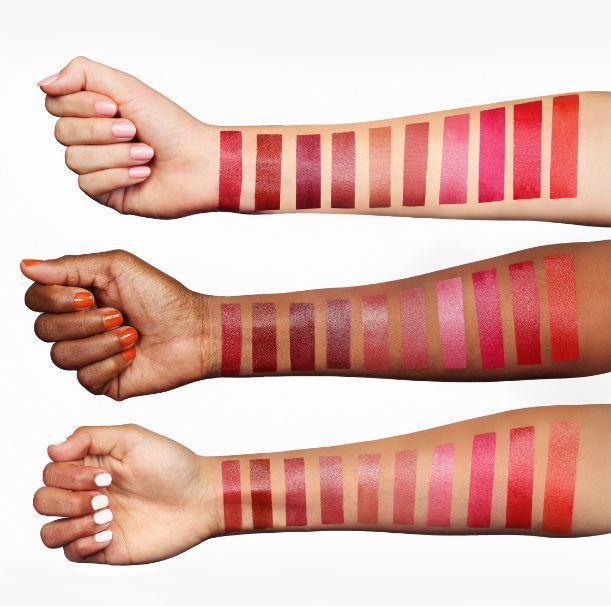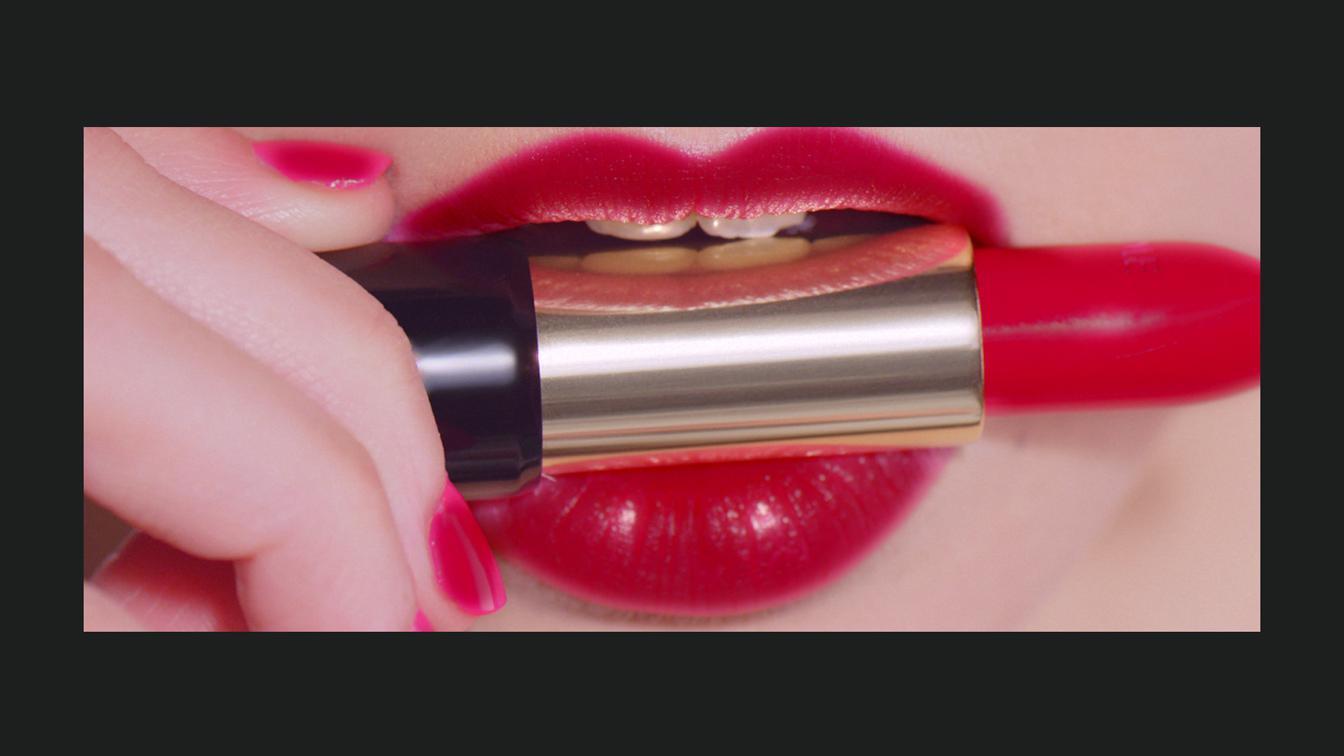The first image is the image on the left, the second image is the image on the right. For the images shown, is this caption "One image shows exactly six different lipstick color samples." true? Answer yes or no. No. The first image is the image on the left, the second image is the image on the right. Considering the images on both sides, is "There are 6 shades of lipstick presented in the image on the right." valid? Answer yes or no. No. 